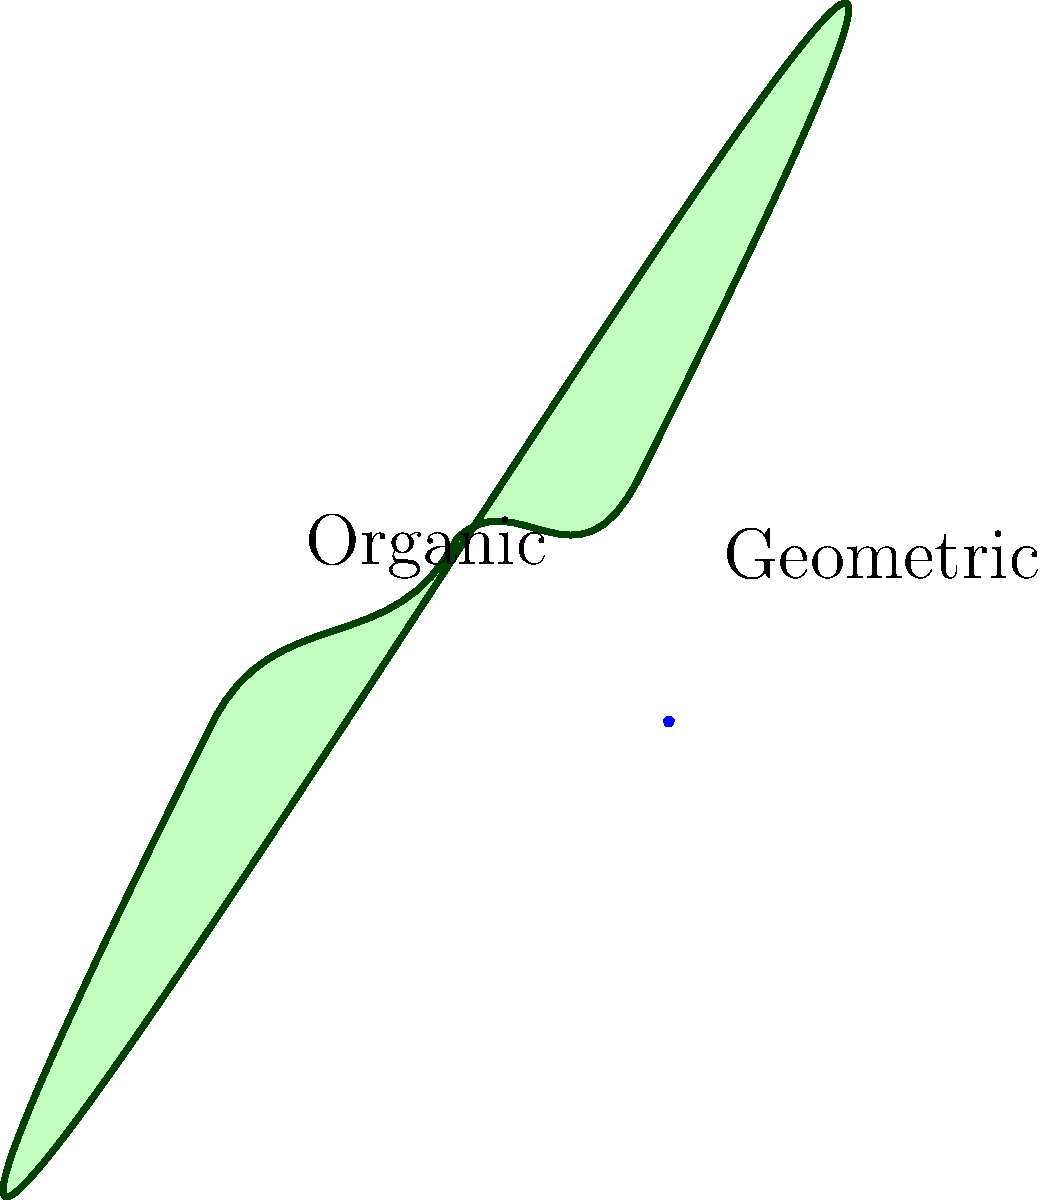Como as formas orgânicas nas esculturas de Angelo Venosa se diferem das formas geométricas regulares em termos de complexidade visual e impacto emocional? Para responder a esta questão, vamos analisar as características das formas orgânicas e geométricas:

1. Formas orgânicas (como nas obras de Venosa):
   - São irregulares e fluidas
   - Têm contornos curvos e imprevisíveis
   - Evocam elementos naturais e biológicos
   - Criam uma sensação de movimento e fluidez

2. Formas geométricas regulares:
   - São simétricas e previsíveis
   - Têm contornos retos ou curvas matemáticas precisas
   - Evocam estruturas artificiais e construídas
   - Criam uma sensação de estabilidade e ordem

3. Complexidade visual:
   - As formas orgânicas de Venosa são geralmente mais complexas visualmente
   - Elas exigem mais tempo para serem compreendidas e apreciadas
   - Oferecem mais detalhes e nuances para explorar

4. Impacto emocional:
   - As formas orgânicas tendem a evocar emoções mais suaves e naturais
   - Podem criar uma conexão mais intuitiva e pessoal com o observador
   - As formas geométricas, por outro lado, podem evocar sensações de ordem e racionalidade

5. Contraste na obra de Venosa:
   - Venosa frequentemente combina elementos orgânicos com geométricos
   - Isso cria um contraste interessante entre o natural e o artificial
   - Essa justaposição aumenta o impacto visual e emocional de suas esculturas
Answer: As formas orgânicas de Venosa são mais complexas visualmente e evocam emoções mais naturais e pessoais, enquanto as formas geométricas são mais previsíveis e transmitem ordem e racionalidade. 